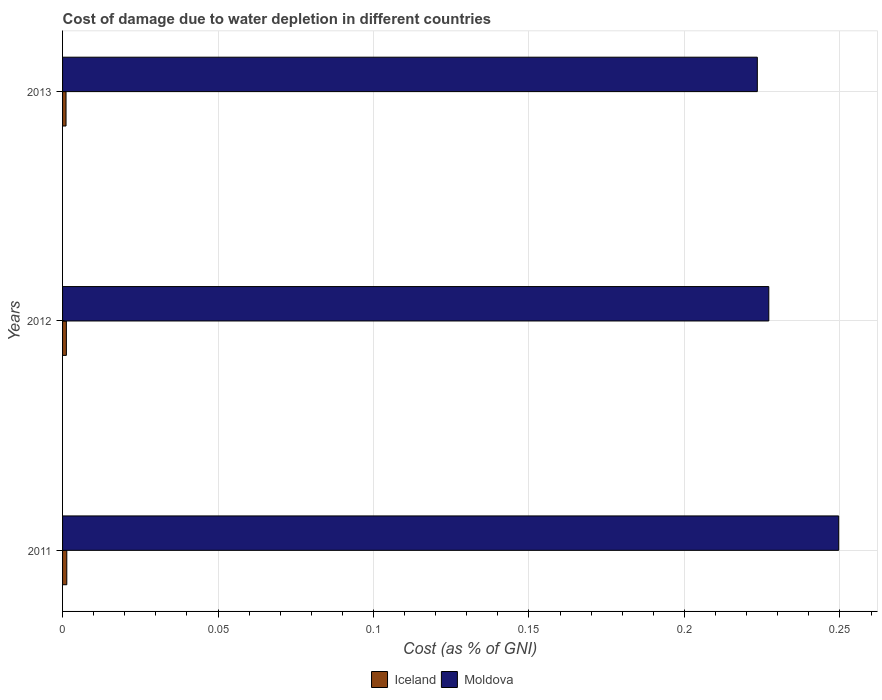How many different coloured bars are there?
Make the answer very short. 2. Are the number of bars per tick equal to the number of legend labels?
Provide a succinct answer. Yes. How many bars are there on the 1st tick from the bottom?
Keep it short and to the point. 2. What is the label of the 3rd group of bars from the top?
Your answer should be compact. 2011. What is the cost of damage caused due to water depletion in Moldova in 2012?
Offer a very short reply. 0.23. Across all years, what is the maximum cost of damage caused due to water depletion in Moldova?
Offer a very short reply. 0.25. Across all years, what is the minimum cost of damage caused due to water depletion in Moldova?
Make the answer very short. 0.22. In which year was the cost of damage caused due to water depletion in Iceland maximum?
Provide a short and direct response. 2011. In which year was the cost of damage caused due to water depletion in Iceland minimum?
Offer a very short reply. 2013. What is the total cost of damage caused due to water depletion in Moldova in the graph?
Offer a very short reply. 0.7. What is the difference between the cost of damage caused due to water depletion in Moldova in 2011 and that in 2013?
Provide a short and direct response. 0.03. What is the difference between the cost of damage caused due to water depletion in Moldova in 2011 and the cost of damage caused due to water depletion in Iceland in 2012?
Provide a succinct answer. 0.25. What is the average cost of damage caused due to water depletion in Moldova per year?
Your answer should be compact. 0.23. In the year 2013, what is the difference between the cost of damage caused due to water depletion in Iceland and cost of damage caused due to water depletion in Moldova?
Offer a terse response. -0.22. What is the ratio of the cost of damage caused due to water depletion in Moldova in 2011 to that in 2012?
Keep it short and to the point. 1.1. Is the cost of damage caused due to water depletion in Iceland in 2012 less than that in 2013?
Your response must be concise. No. What is the difference between the highest and the second highest cost of damage caused due to water depletion in Iceland?
Offer a terse response. 0. What is the difference between the highest and the lowest cost of damage caused due to water depletion in Moldova?
Provide a short and direct response. 0.03. In how many years, is the cost of damage caused due to water depletion in Iceland greater than the average cost of damage caused due to water depletion in Iceland taken over all years?
Your answer should be very brief. 1. What does the 1st bar from the top in 2012 represents?
Ensure brevity in your answer.  Moldova. What does the 1st bar from the bottom in 2011 represents?
Offer a very short reply. Iceland. How many bars are there?
Keep it short and to the point. 6. Are all the bars in the graph horizontal?
Make the answer very short. Yes. What is the difference between two consecutive major ticks on the X-axis?
Offer a terse response. 0.05. Does the graph contain any zero values?
Your answer should be compact. No. Does the graph contain grids?
Your answer should be compact. Yes. How many legend labels are there?
Offer a very short reply. 2. What is the title of the graph?
Your response must be concise. Cost of damage due to water depletion in different countries. What is the label or title of the X-axis?
Ensure brevity in your answer.  Cost (as % of GNI). What is the label or title of the Y-axis?
Provide a succinct answer. Years. What is the Cost (as % of GNI) in Iceland in 2011?
Keep it short and to the point. 0. What is the Cost (as % of GNI) of Moldova in 2011?
Give a very brief answer. 0.25. What is the Cost (as % of GNI) in Iceland in 2012?
Your answer should be very brief. 0. What is the Cost (as % of GNI) of Moldova in 2012?
Keep it short and to the point. 0.23. What is the Cost (as % of GNI) in Iceland in 2013?
Your response must be concise. 0. What is the Cost (as % of GNI) of Moldova in 2013?
Keep it short and to the point. 0.22. Across all years, what is the maximum Cost (as % of GNI) of Iceland?
Keep it short and to the point. 0. Across all years, what is the maximum Cost (as % of GNI) of Moldova?
Ensure brevity in your answer.  0.25. Across all years, what is the minimum Cost (as % of GNI) in Iceland?
Offer a very short reply. 0. Across all years, what is the minimum Cost (as % of GNI) in Moldova?
Keep it short and to the point. 0.22. What is the total Cost (as % of GNI) of Iceland in the graph?
Your response must be concise. 0. What is the total Cost (as % of GNI) of Moldova in the graph?
Keep it short and to the point. 0.7. What is the difference between the Cost (as % of GNI) in Iceland in 2011 and that in 2012?
Offer a terse response. 0. What is the difference between the Cost (as % of GNI) in Moldova in 2011 and that in 2012?
Ensure brevity in your answer.  0.02. What is the difference between the Cost (as % of GNI) of Iceland in 2011 and that in 2013?
Provide a short and direct response. 0. What is the difference between the Cost (as % of GNI) in Moldova in 2011 and that in 2013?
Provide a short and direct response. 0.03. What is the difference between the Cost (as % of GNI) of Iceland in 2012 and that in 2013?
Give a very brief answer. 0. What is the difference between the Cost (as % of GNI) in Moldova in 2012 and that in 2013?
Your answer should be very brief. 0. What is the difference between the Cost (as % of GNI) in Iceland in 2011 and the Cost (as % of GNI) in Moldova in 2012?
Your response must be concise. -0.23. What is the difference between the Cost (as % of GNI) of Iceland in 2011 and the Cost (as % of GNI) of Moldova in 2013?
Keep it short and to the point. -0.22. What is the difference between the Cost (as % of GNI) in Iceland in 2012 and the Cost (as % of GNI) in Moldova in 2013?
Give a very brief answer. -0.22. What is the average Cost (as % of GNI) of Iceland per year?
Provide a short and direct response. 0. What is the average Cost (as % of GNI) of Moldova per year?
Your answer should be compact. 0.23. In the year 2011, what is the difference between the Cost (as % of GNI) of Iceland and Cost (as % of GNI) of Moldova?
Give a very brief answer. -0.25. In the year 2012, what is the difference between the Cost (as % of GNI) in Iceland and Cost (as % of GNI) in Moldova?
Give a very brief answer. -0.23. In the year 2013, what is the difference between the Cost (as % of GNI) in Iceland and Cost (as % of GNI) in Moldova?
Provide a short and direct response. -0.22. What is the ratio of the Cost (as % of GNI) in Iceland in 2011 to that in 2012?
Provide a short and direct response. 1.11. What is the ratio of the Cost (as % of GNI) in Moldova in 2011 to that in 2012?
Ensure brevity in your answer.  1.1. What is the ratio of the Cost (as % of GNI) in Iceland in 2011 to that in 2013?
Offer a terse response. 1.22. What is the ratio of the Cost (as % of GNI) of Moldova in 2011 to that in 2013?
Your response must be concise. 1.12. What is the ratio of the Cost (as % of GNI) of Iceland in 2012 to that in 2013?
Offer a very short reply. 1.1. What is the ratio of the Cost (as % of GNI) of Moldova in 2012 to that in 2013?
Make the answer very short. 1.02. What is the difference between the highest and the second highest Cost (as % of GNI) in Moldova?
Offer a very short reply. 0.02. What is the difference between the highest and the lowest Cost (as % of GNI) in Iceland?
Your answer should be compact. 0. What is the difference between the highest and the lowest Cost (as % of GNI) in Moldova?
Your response must be concise. 0.03. 